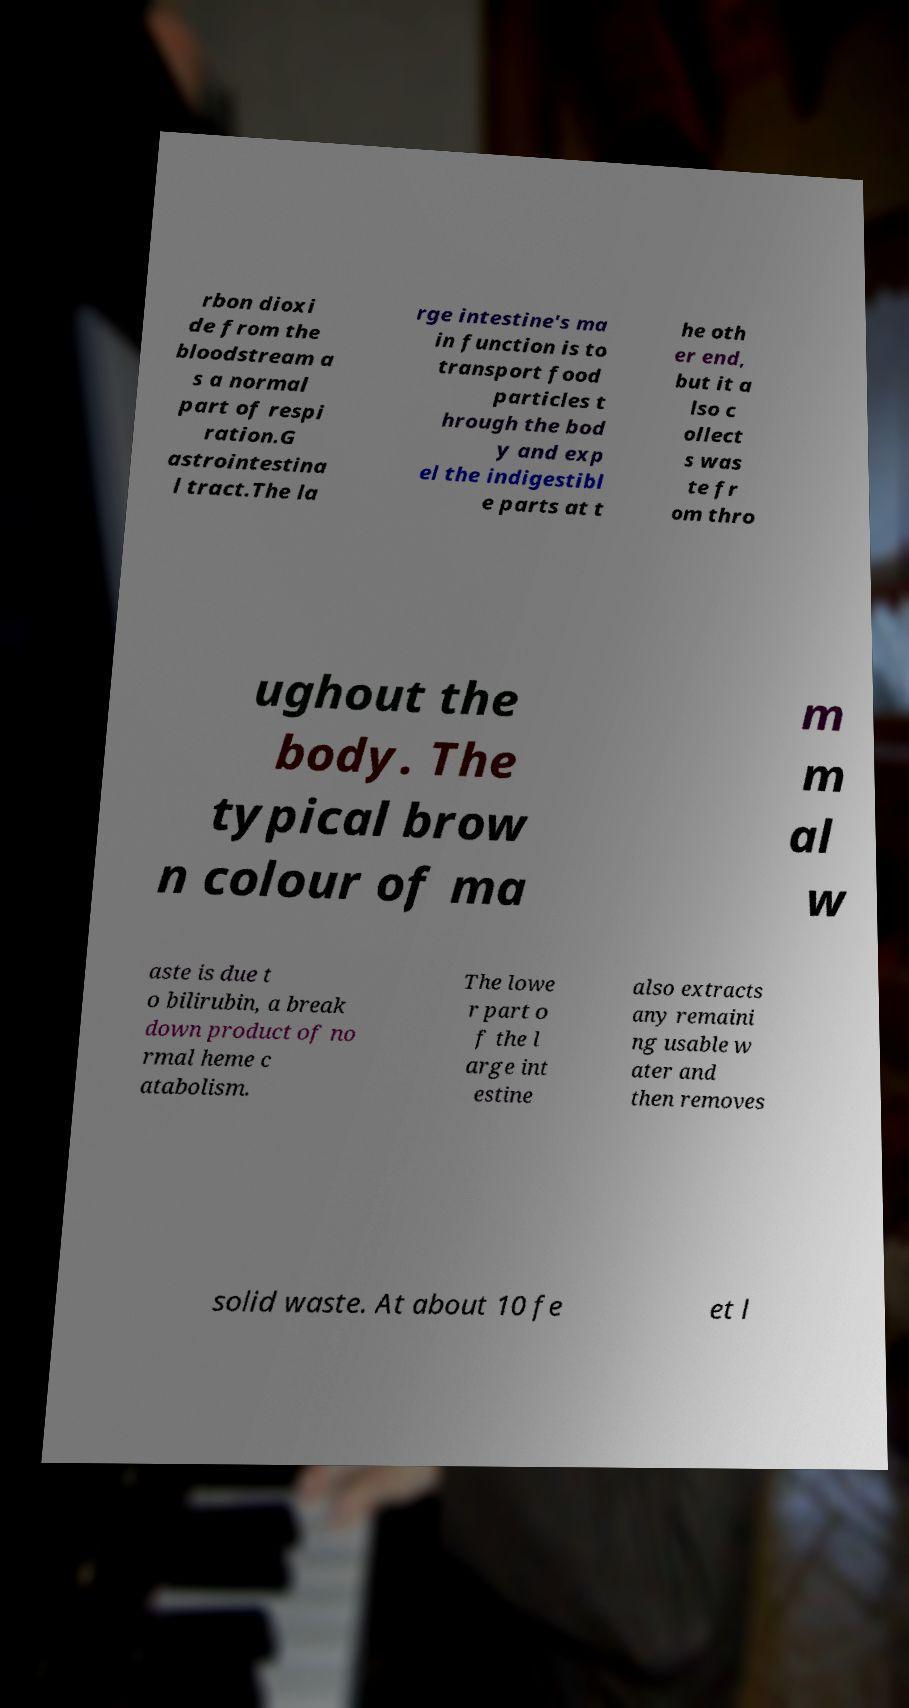I need the written content from this picture converted into text. Can you do that? rbon dioxi de from the bloodstream a s a normal part of respi ration.G astrointestina l tract.The la rge intestine's ma in function is to transport food particles t hrough the bod y and exp el the indigestibl e parts at t he oth er end, but it a lso c ollect s was te fr om thro ughout the body. The typical brow n colour of ma m m al w aste is due t o bilirubin, a break down product of no rmal heme c atabolism. The lowe r part o f the l arge int estine also extracts any remaini ng usable w ater and then removes solid waste. At about 10 fe et l 